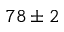<formula> <loc_0><loc_0><loc_500><loc_500>7 8 \pm 2</formula> 